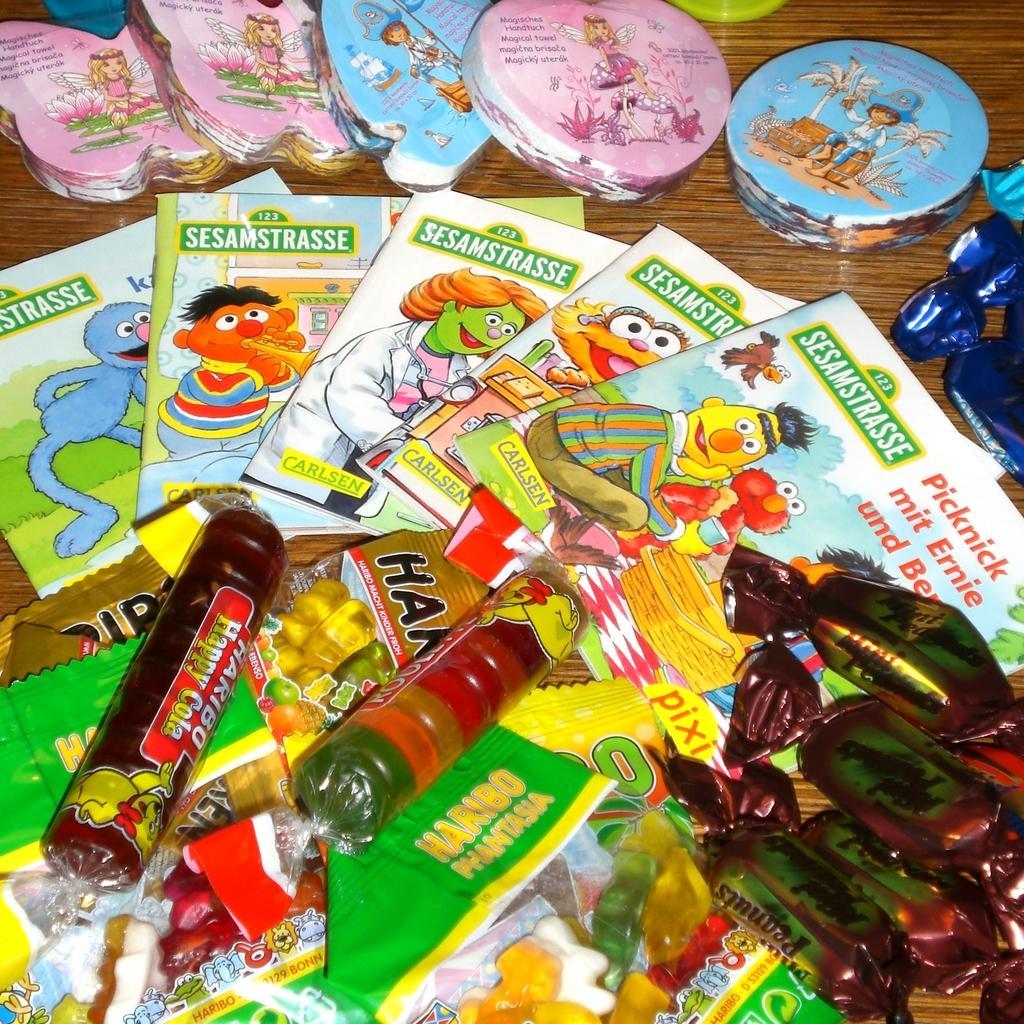Please provide a concise description of this image. In this image on the table there are chocolates, books, candies and few other objects. 